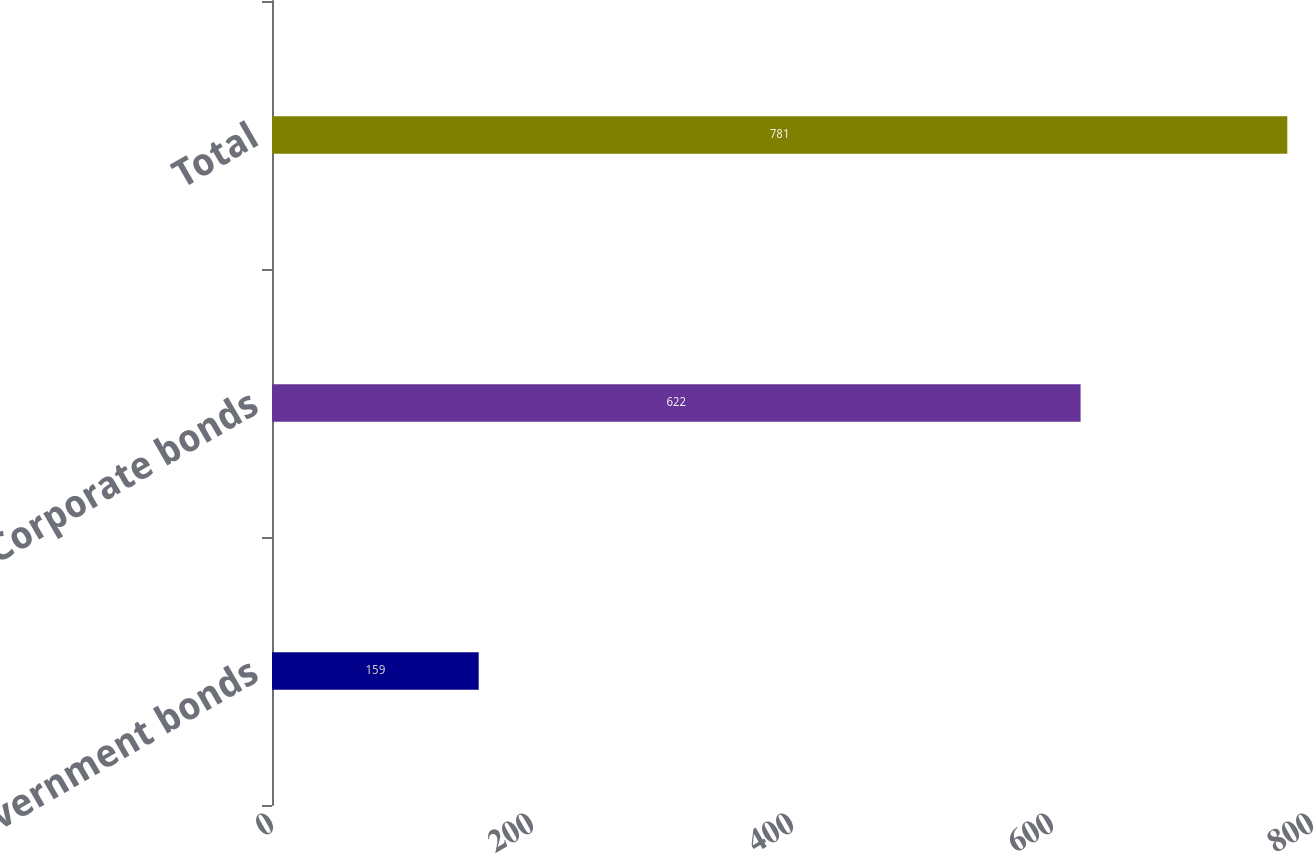Convert chart to OTSL. <chart><loc_0><loc_0><loc_500><loc_500><bar_chart><fcel>Government bonds<fcel>Corporate bonds<fcel>Total<nl><fcel>159<fcel>622<fcel>781<nl></chart> 